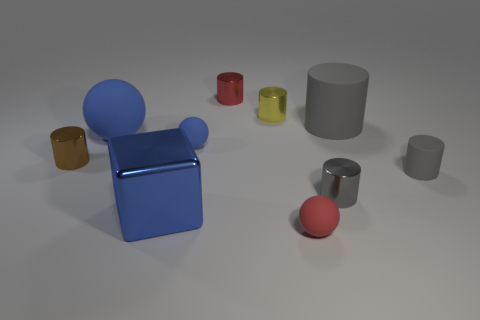Are there any objects in the image that have similar colors but different shapes? Yes, the pink sphere and the smaller red cylinder have similar colors yet they differ in shape, with one being a sphere and the other a cylinder. Can you tell me the number of objects that have circular bases? Certainly, there are five objects with circular bases: the two large cylinders, and the three smaller cylinders. 